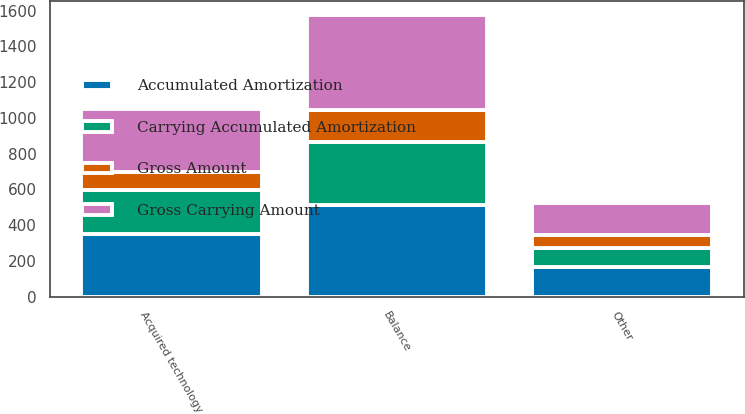<chart> <loc_0><loc_0><loc_500><loc_500><stacked_bar_chart><ecel><fcel>Acquired technology<fcel>Other<fcel>Balance<nl><fcel>Gross Carrying Amount<fcel>352<fcel>179<fcel>531<nl><fcel>Gross Amount<fcel>104<fcel>76<fcel>180<nl><fcel>Carrying Accumulated Amortization<fcel>248<fcel>103<fcel>351<nl><fcel>Accumulated Amortization<fcel>348<fcel>167<fcel>515<nl></chart> 